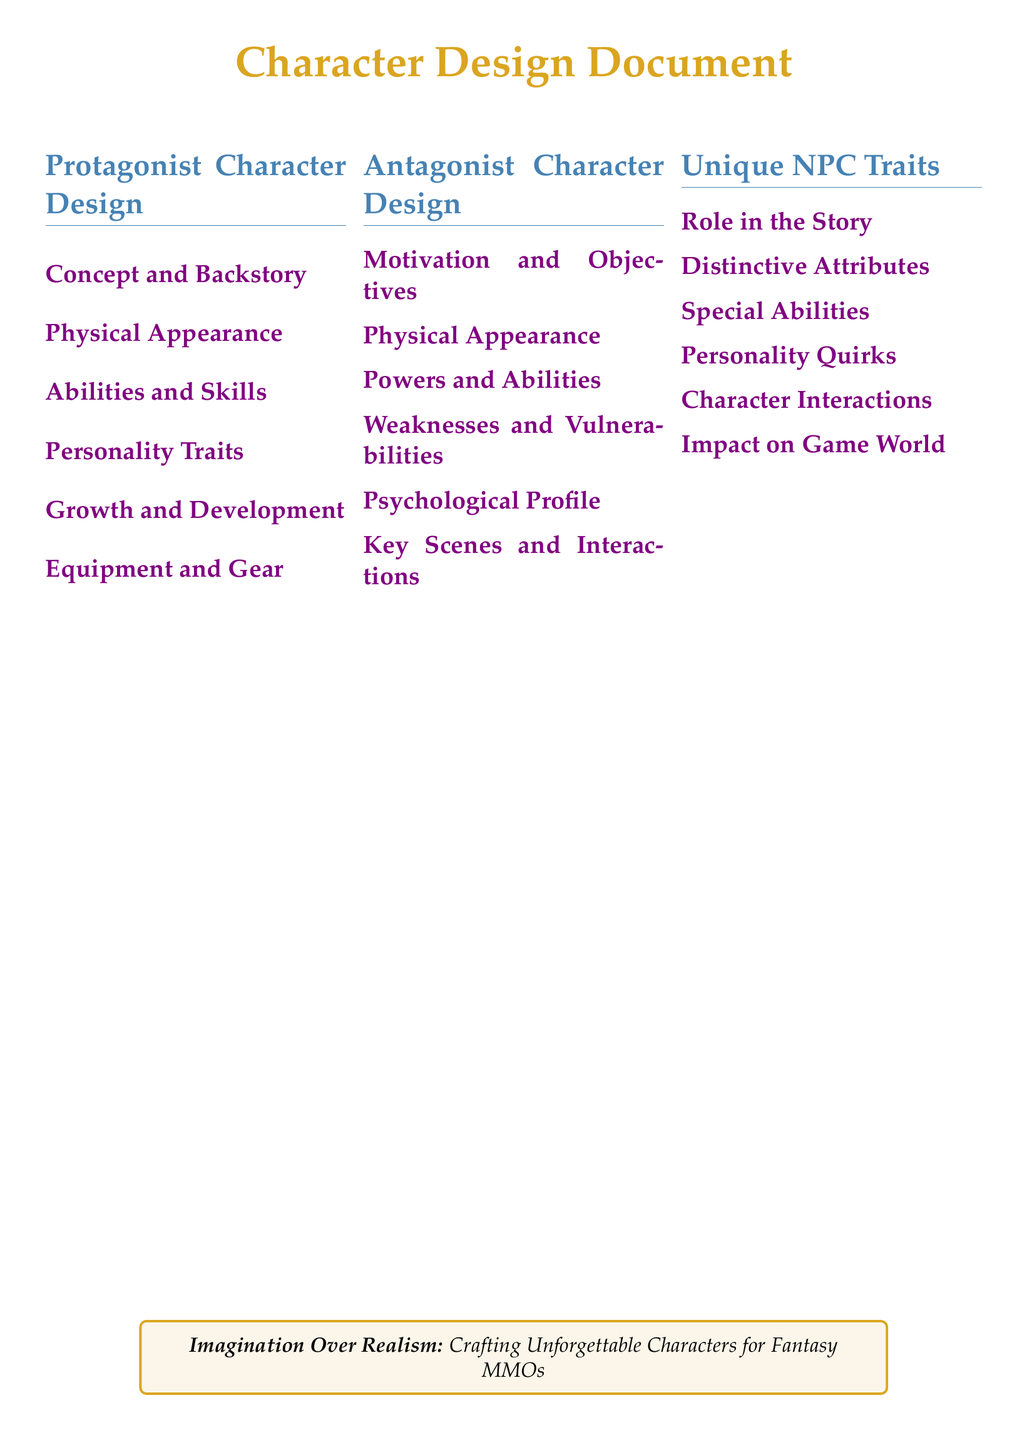What is the title of the document? The title is prominently displayed at the beginning of the document.
Answer: Character Design Document How many main sections are there? Each main section is labeled in the Table of Contents; counting them gives the total.
Answer: 3 What is the color used for the protagonist section? The document specifies a color for each section heading.
Answer: fantasyblue Which trait is listed under Unique NPC Traits? The document includes specific traits that describe unique characteristics of NPCs.
Answer: Distinctive Attributes What does the antagonist's psychological profile describe? This subsection focuses on the mental and emotional aspects of the antagonist.
Answer: Psychological Profile What theme is highlighted in the tcolorbox? The tcolorbox provides a thematic statement regarding character crafting.
Answer: Imagination Over Realism What does the protagonist's section include about their abilities? This part outlines the skills associated with the protagonist character.
Answer: Abilities and Skills What is included in the Antagonist Character Design regarding their appearance? A specific aspect of the antagonist that is described in this section.
Answer: Physical Appearance What type of traits are NPCs described to have? The traits in this section indicate individual characteristics that make them unique.
Answer: Personality Quirks 